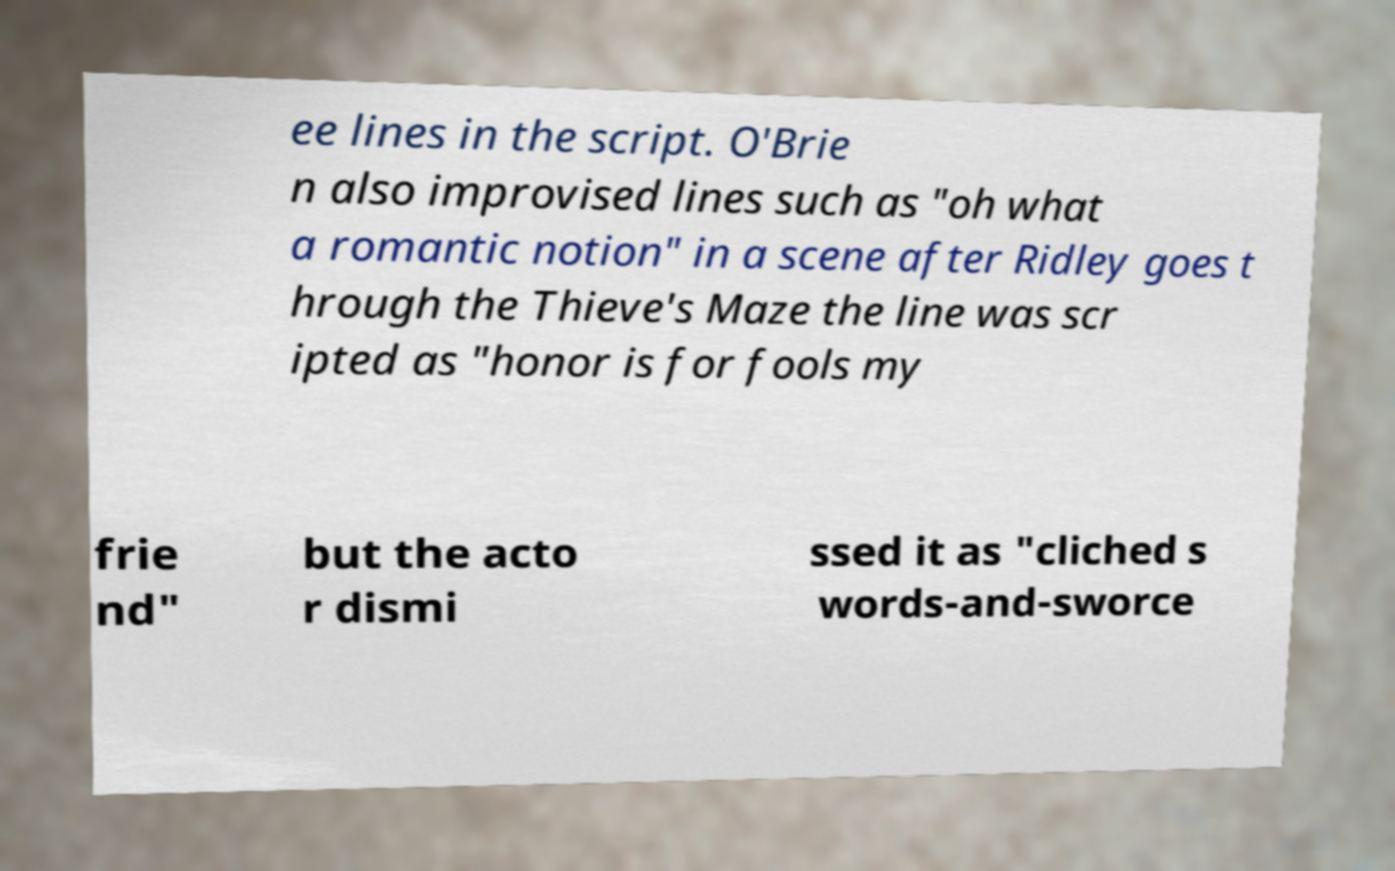What messages or text are displayed in this image? I need them in a readable, typed format. ee lines in the script. O'Brie n also improvised lines such as "oh what a romantic notion" in a scene after Ridley goes t hrough the Thieve's Maze the line was scr ipted as "honor is for fools my frie nd" but the acto r dismi ssed it as "cliched s words-and-sworce 